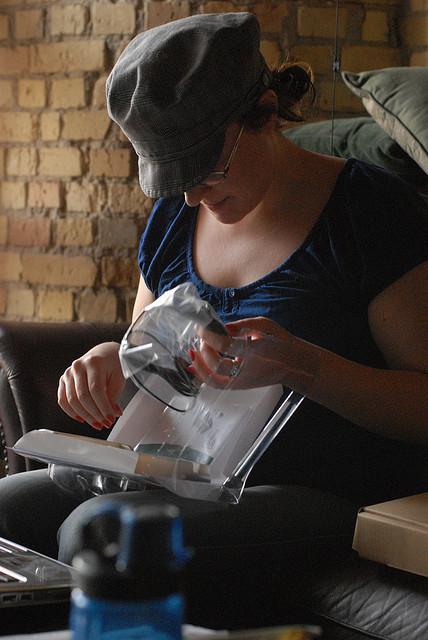What color is the lady's hat?
Keep it brief. Gray. What is in the immediate foreground?
Give a very brief answer. Water bottle. Is the woman sewing?
Give a very brief answer. No. 